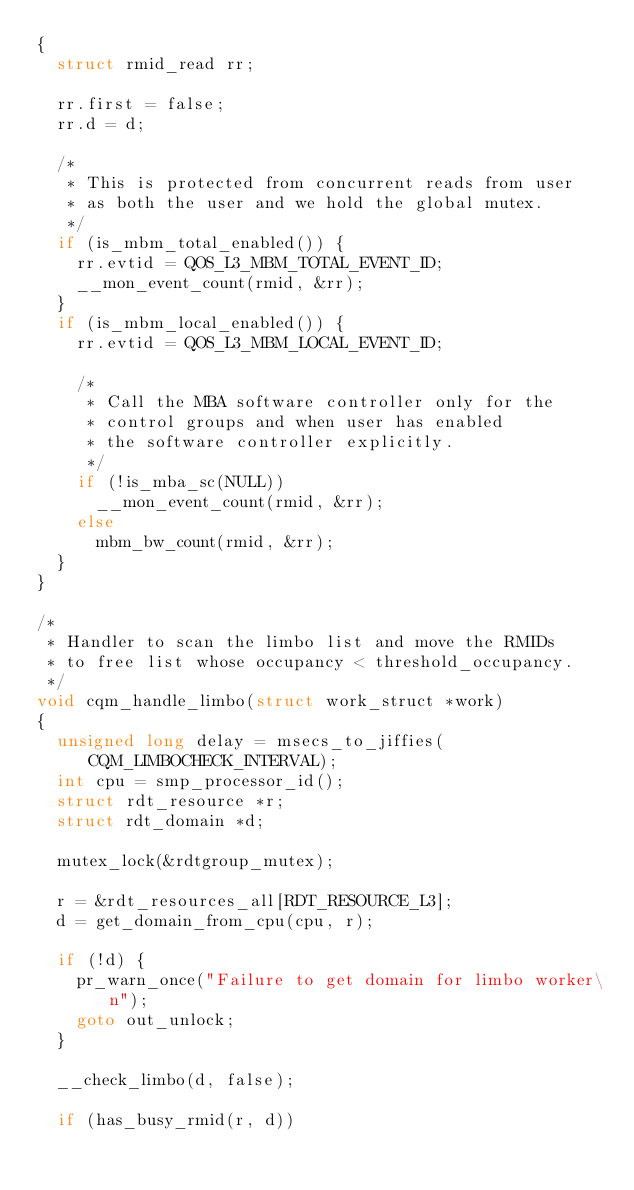<code> <loc_0><loc_0><loc_500><loc_500><_C_>{
	struct rmid_read rr;

	rr.first = false;
	rr.d = d;

	/*
	 * This is protected from concurrent reads from user
	 * as both the user and we hold the global mutex.
	 */
	if (is_mbm_total_enabled()) {
		rr.evtid = QOS_L3_MBM_TOTAL_EVENT_ID;
		__mon_event_count(rmid, &rr);
	}
	if (is_mbm_local_enabled()) {
		rr.evtid = QOS_L3_MBM_LOCAL_EVENT_ID;

		/*
		 * Call the MBA software controller only for the
		 * control groups and when user has enabled
		 * the software controller explicitly.
		 */
		if (!is_mba_sc(NULL))
			__mon_event_count(rmid, &rr);
		else
			mbm_bw_count(rmid, &rr);
	}
}

/*
 * Handler to scan the limbo list and move the RMIDs
 * to free list whose occupancy < threshold_occupancy.
 */
void cqm_handle_limbo(struct work_struct *work)
{
	unsigned long delay = msecs_to_jiffies(CQM_LIMBOCHECK_INTERVAL);
	int cpu = smp_processor_id();
	struct rdt_resource *r;
	struct rdt_domain *d;

	mutex_lock(&rdtgroup_mutex);

	r = &rdt_resources_all[RDT_RESOURCE_L3];
	d = get_domain_from_cpu(cpu, r);

	if (!d) {
		pr_warn_once("Failure to get domain for limbo worker\n");
		goto out_unlock;
	}

	__check_limbo(d, false);

	if (has_busy_rmid(r, d))</code> 